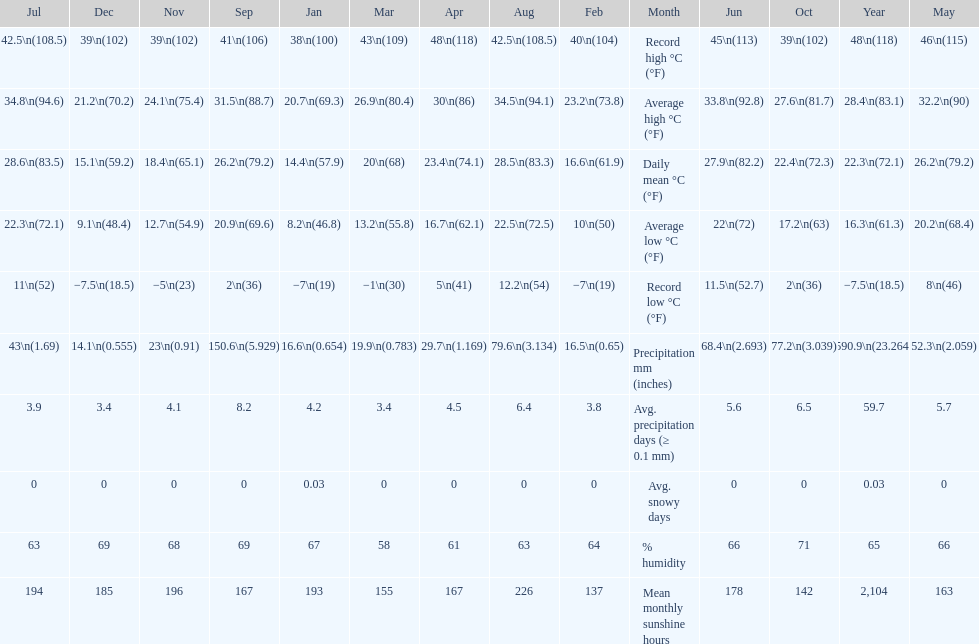Does december or january have more snow days? January. 